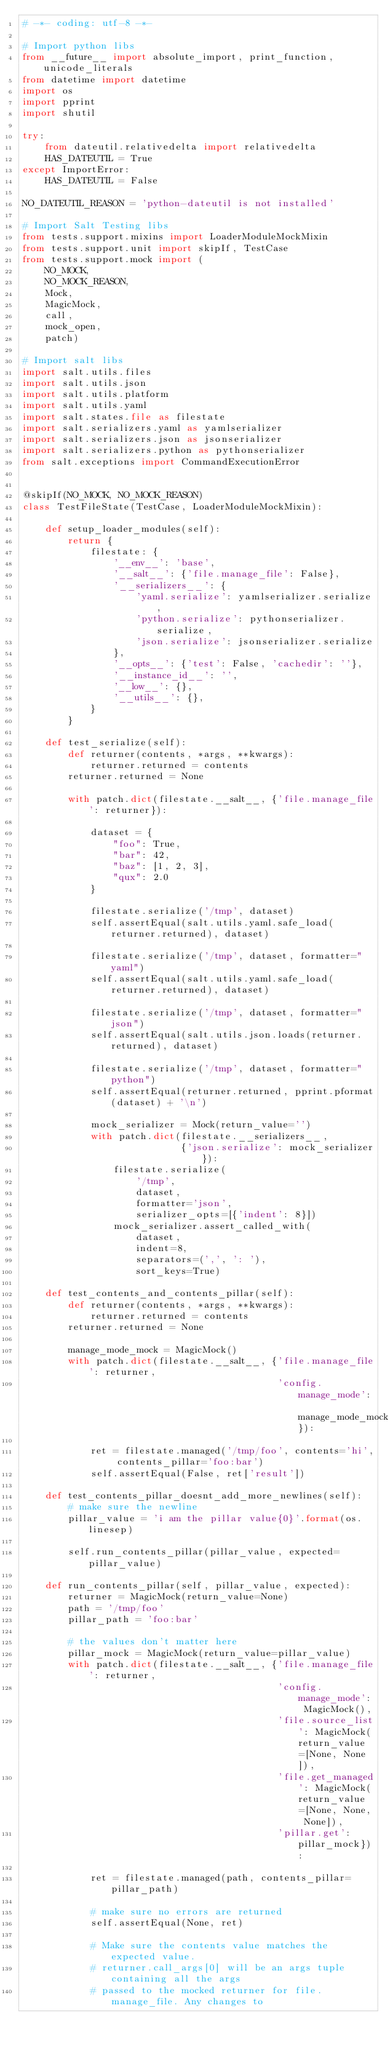Convert code to text. <code><loc_0><loc_0><loc_500><loc_500><_Python_># -*- coding: utf-8 -*-

# Import python libs
from __future__ import absolute_import, print_function, unicode_literals
from datetime import datetime
import os
import pprint
import shutil

try:
    from dateutil.relativedelta import relativedelta
    HAS_DATEUTIL = True
except ImportError:
    HAS_DATEUTIL = False

NO_DATEUTIL_REASON = 'python-dateutil is not installed'

# Import Salt Testing libs
from tests.support.mixins import LoaderModuleMockMixin
from tests.support.unit import skipIf, TestCase
from tests.support.mock import (
    NO_MOCK,
    NO_MOCK_REASON,
    Mock,
    MagicMock,
    call,
    mock_open,
    patch)

# Import salt libs
import salt.utils.files
import salt.utils.json
import salt.utils.platform
import salt.utils.yaml
import salt.states.file as filestate
import salt.serializers.yaml as yamlserializer
import salt.serializers.json as jsonserializer
import salt.serializers.python as pythonserializer
from salt.exceptions import CommandExecutionError


@skipIf(NO_MOCK, NO_MOCK_REASON)
class TestFileState(TestCase, LoaderModuleMockMixin):

    def setup_loader_modules(self):
        return {
            filestate: {
                '__env__': 'base',
                '__salt__': {'file.manage_file': False},
                '__serializers__': {
                    'yaml.serialize': yamlserializer.serialize,
                    'python.serialize': pythonserializer.serialize,
                    'json.serialize': jsonserializer.serialize
                },
                '__opts__': {'test': False, 'cachedir': ''},
                '__instance_id__': '',
                '__low__': {},
                '__utils__': {},
            }
        }

    def test_serialize(self):
        def returner(contents, *args, **kwargs):
            returner.returned = contents
        returner.returned = None

        with patch.dict(filestate.__salt__, {'file.manage_file': returner}):

            dataset = {
                "foo": True,
                "bar": 42,
                "baz": [1, 2, 3],
                "qux": 2.0
            }

            filestate.serialize('/tmp', dataset)
            self.assertEqual(salt.utils.yaml.safe_load(returner.returned), dataset)

            filestate.serialize('/tmp', dataset, formatter="yaml")
            self.assertEqual(salt.utils.yaml.safe_load(returner.returned), dataset)

            filestate.serialize('/tmp', dataset, formatter="json")
            self.assertEqual(salt.utils.json.loads(returner.returned), dataset)

            filestate.serialize('/tmp', dataset, formatter="python")
            self.assertEqual(returner.returned, pprint.pformat(dataset) + '\n')

            mock_serializer = Mock(return_value='')
            with patch.dict(filestate.__serializers__,
                            {'json.serialize': mock_serializer}):
                filestate.serialize(
                    '/tmp',
                    dataset,
                    formatter='json',
                    serializer_opts=[{'indent': 8}])
                mock_serializer.assert_called_with(
                    dataset,
                    indent=8,
                    separators=(',', ': '),
                    sort_keys=True)

    def test_contents_and_contents_pillar(self):
        def returner(contents, *args, **kwargs):
            returner.returned = contents
        returner.returned = None

        manage_mode_mock = MagicMock()
        with patch.dict(filestate.__salt__, {'file.manage_file': returner,
                                             'config.manage_mode': manage_mode_mock}):

            ret = filestate.managed('/tmp/foo', contents='hi', contents_pillar='foo:bar')
            self.assertEqual(False, ret['result'])

    def test_contents_pillar_doesnt_add_more_newlines(self):
        # make sure the newline
        pillar_value = 'i am the pillar value{0}'.format(os.linesep)

        self.run_contents_pillar(pillar_value, expected=pillar_value)

    def run_contents_pillar(self, pillar_value, expected):
        returner = MagicMock(return_value=None)
        path = '/tmp/foo'
        pillar_path = 'foo:bar'

        # the values don't matter here
        pillar_mock = MagicMock(return_value=pillar_value)
        with patch.dict(filestate.__salt__, {'file.manage_file': returner,
                                             'config.manage_mode': MagicMock(),
                                             'file.source_list': MagicMock(return_value=[None, None]),
                                             'file.get_managed': MagicMock(return_value=[None, None, None]),
                                             'pillar.get': pillar_mock}):

            ret = filestate.managed(path, contents_pillar=pillar_path)

            # make sure no errors are returned
            self.assertEqual(None, ret)

            # Make sure the contents value matches the expected value.
            # returner.call_args[0] will be an args tuple containing all the args
            # passed to the mocked returner for file.manage_file. Any changes to</code> 